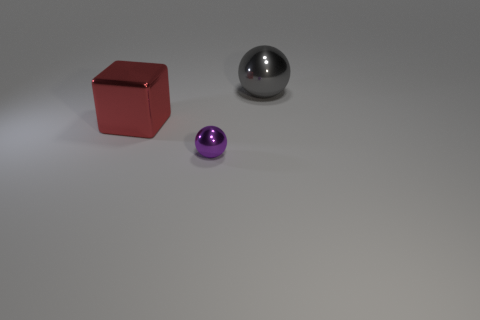Add 2 small purple spheres. How many objects exist? 5 Subtract all blocks. How many objects are left? 2 Add 3 tiny spheres. How many tiny spheres exist? 4 Subtract 0 gray cubes. How many objects are left? 3 Subtract all brown metal things. Subtract all small balls. How many objects are left? 2 Add 2 cubes. How many cubes are left? 3 